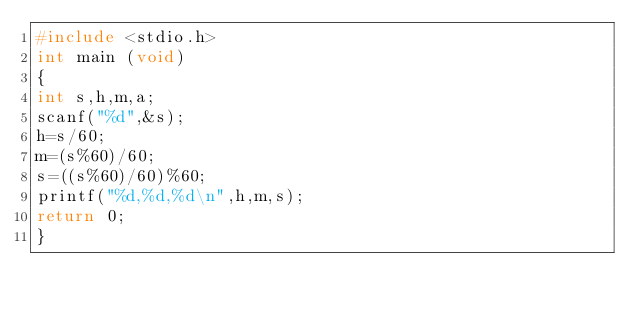<code> <loc_0><loc_0><loc_500><loc_500><_C_>#include <stdio.h>
int main (void)
{
int s,h,m,a;
scanf("%d",&s);
h=s/60;
m=(s%60)/60;
s=((s%60)/60)%60;
printf("%d,%d,%d\n",h,m,s);
return 0;
}</code> 